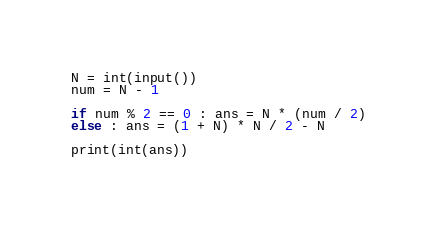<code> <loc_0><loc_0><loc_500><loc_500><_Python_>N = int(input())
num = N - 1

if num % 2 == 0 : ans = N * (num / 2)
else : ans = (1 + N) * N / 2 - N 

print(int(ans))</code> 